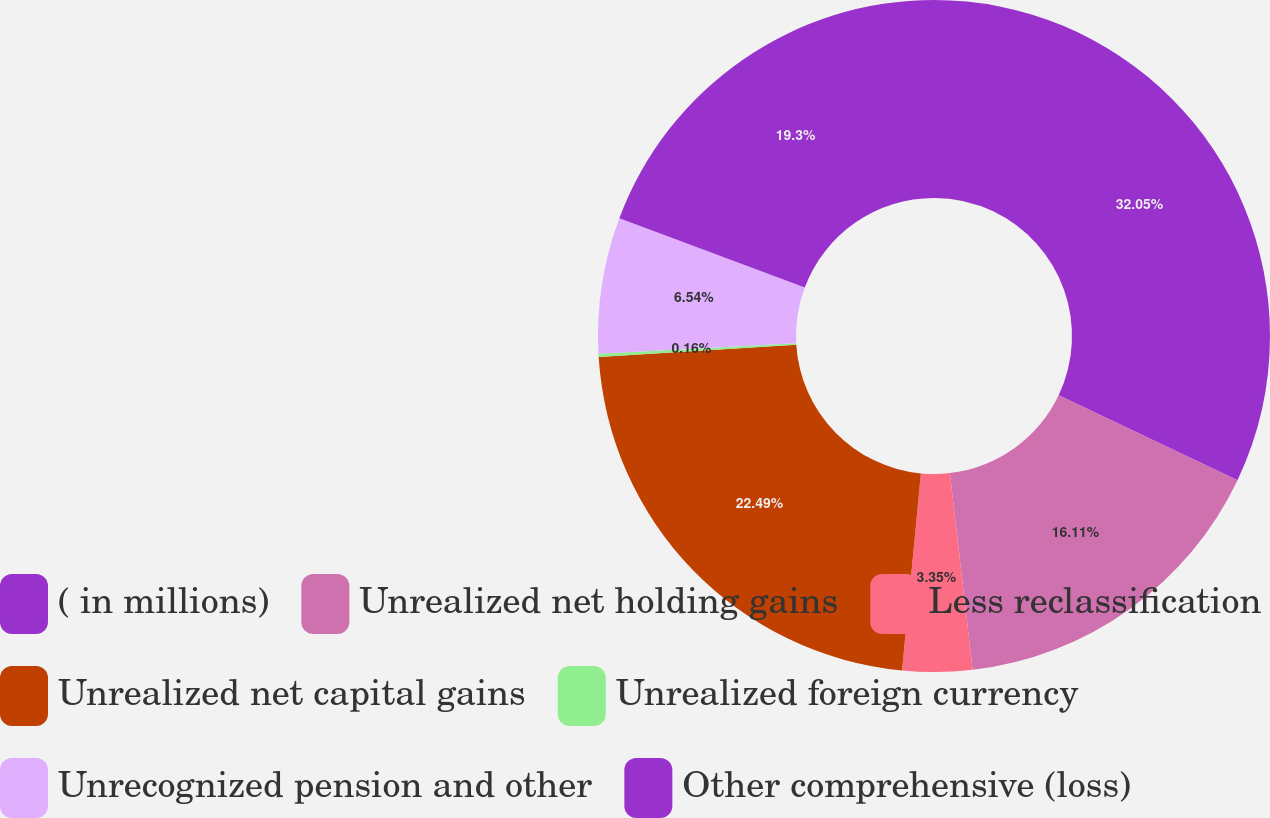<chart> <loc_0><loc_0><loc_500><loc_500><pie_chart><fcel>( in millions)<fcel>Unrealized net holding gains<fcel>Less reclassification<fcel>Unrealized net capital gains<fcel>Unrealized foreign currency<fcel>Unrecognized pension and other<fcel>Other comprehensive (loss)<nl><fcel>32.06%<fcel>16.11%<fcel>3.35%<fcel>22.49%<fcel>0.16%<fcel>6.54%<fcel>19.3%<nl></chart> 